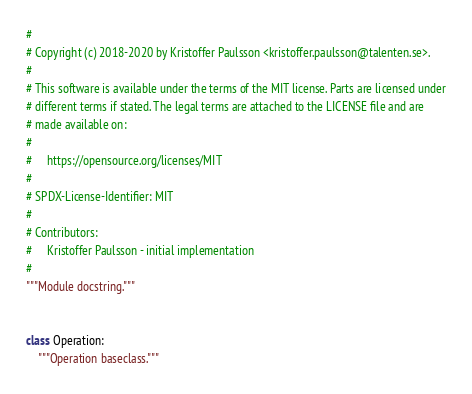Convert code to text. <code><loc_0><loc_0><loc_500><loc_500><_Cython_>#
# Copyright (c) 2018-2020 by Kristoffer Paulsson <kristoffer.paulsson@talenten.se>.
#
# This software is available under the terms of the MIT license. Parts are licensed under
# different terms if stated. The legal terms are attached to the LICENSE file and are
# made available on:
#
#     https://opensource.org/licenses/MIT
#
# SPDX-License-Identifier: MIT
#
# Contributors:
#     Kristoffer Paulsson - initial implementation
#
"""Module docstring."""


class Operation:
    """Operation baseclass."""
</code> 